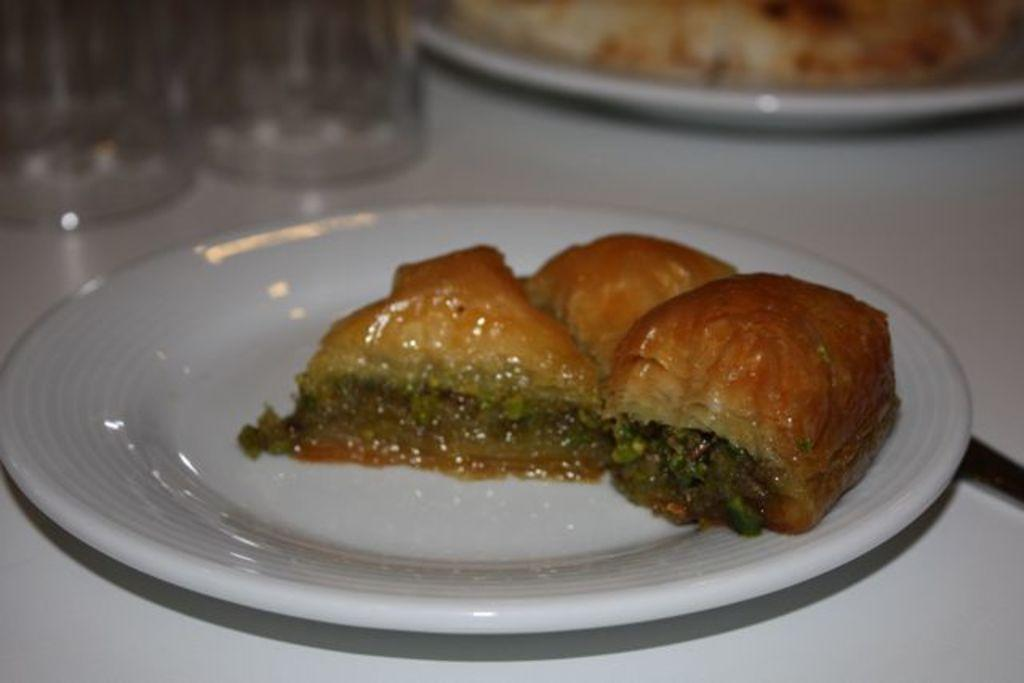What is on the table in the image? There is a plate with food and two glasses on the table. Are there any other plates with food on the table? Yes, there is another plate with food on the table. What type of property is being discussed by the spy in the image? There is no spy or property present in the image; it only shows a table with plates of food and glasses. 